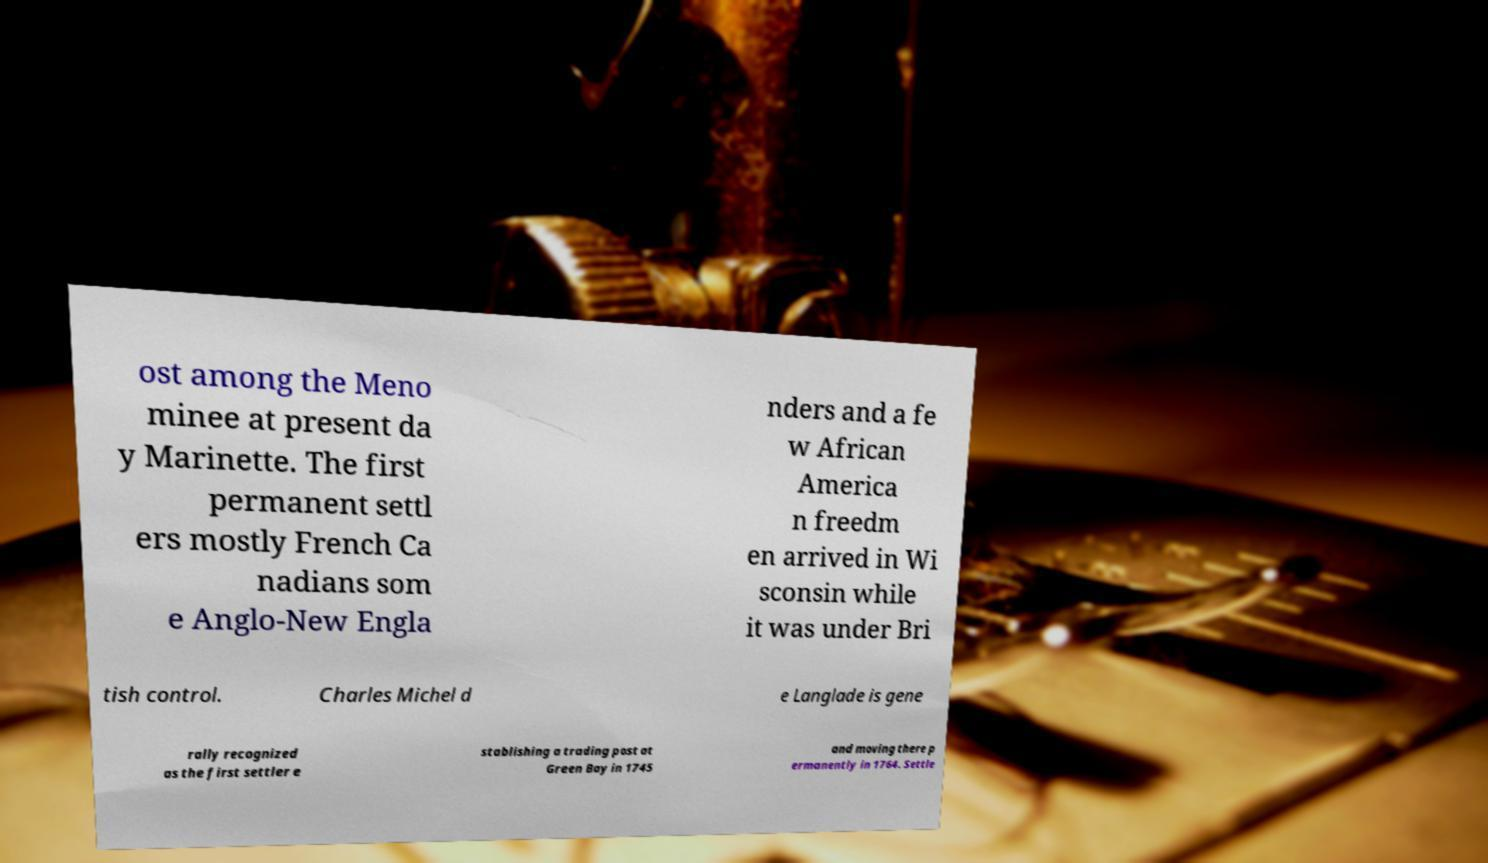What messages or text are displayed in this image? I need them in a readable, typed format. ost among the Meno minee at present da y Marinette. The first permanent settl ers mostly French Ca nadians som e Anglo-New Engla nders and a fe w African America n freedm en arrived in Wi sconsin while it was under Bri tish control. Charles Michel d e Langlade is gene rally recognized as the first settler e stablishing a trading post at Green Bay in 1745 and moving there p ermanently in 1764. Settle 